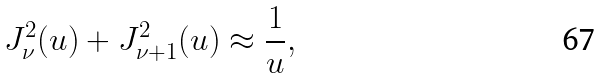Convert formula to latex. <formula><loc_0><loc_0><loc_500><loc_500>J ^ { 2 } _ { \nu } ( u ) + J ^ { 2 } _ { \nu + 1 } ( u ) \approx \frac { 1 } { u } ,</formula> 